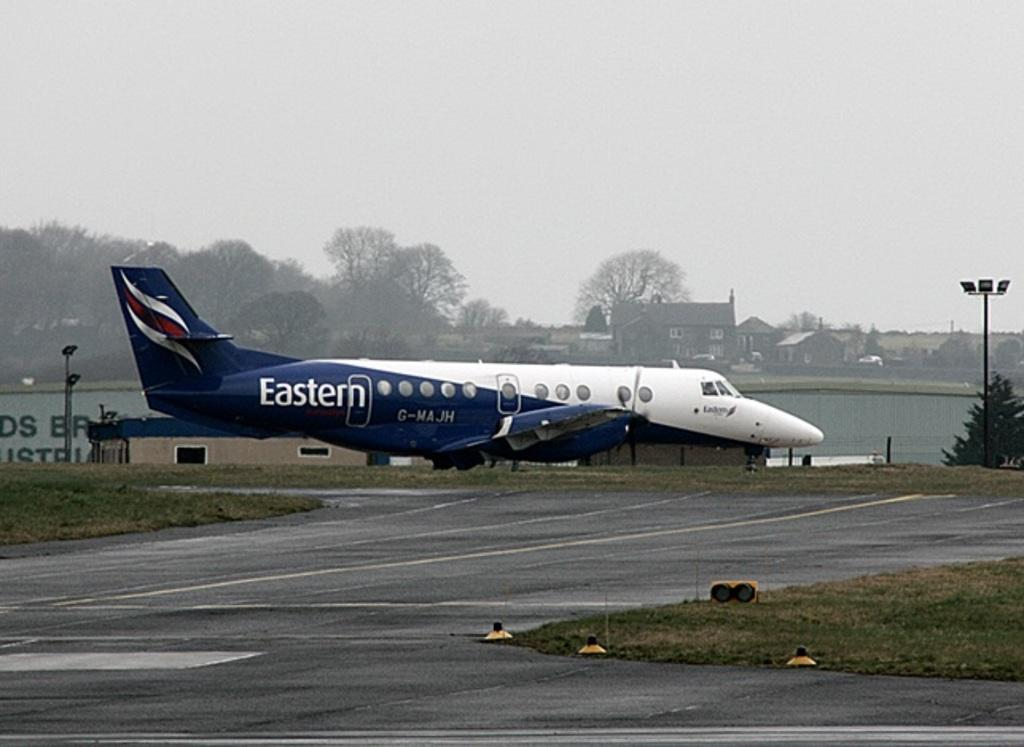<image>
Give a short and clear explanation of the subsequent image. a plane that has the word Eastern on the tail of it 